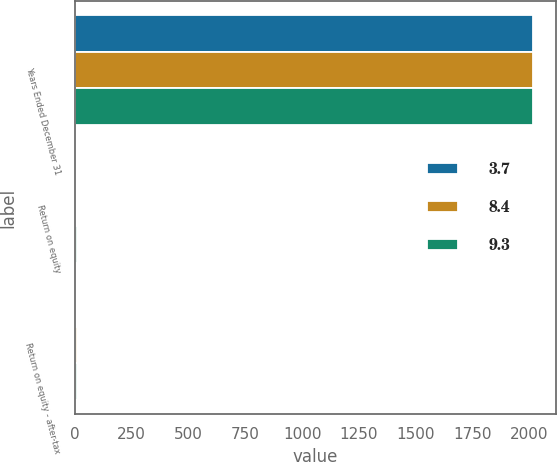<chart> <loc_0><loc_0><loc_500><loc_500><stacked_bar_chart><ecel><fcel>Years Ended December 31<fcel>Return on equity<fcel>Return on equity - after-tax<nl><fcel>3.7<fcel>2015<fcel>2.2<fcel>3.7<nl><fcel>8.4<fcel>2014<fcel>7.1<fcel>8.4<nl><fcel>9.3<fcel>2013<fcel>9.2<fcel>9.3<nl></chart> 